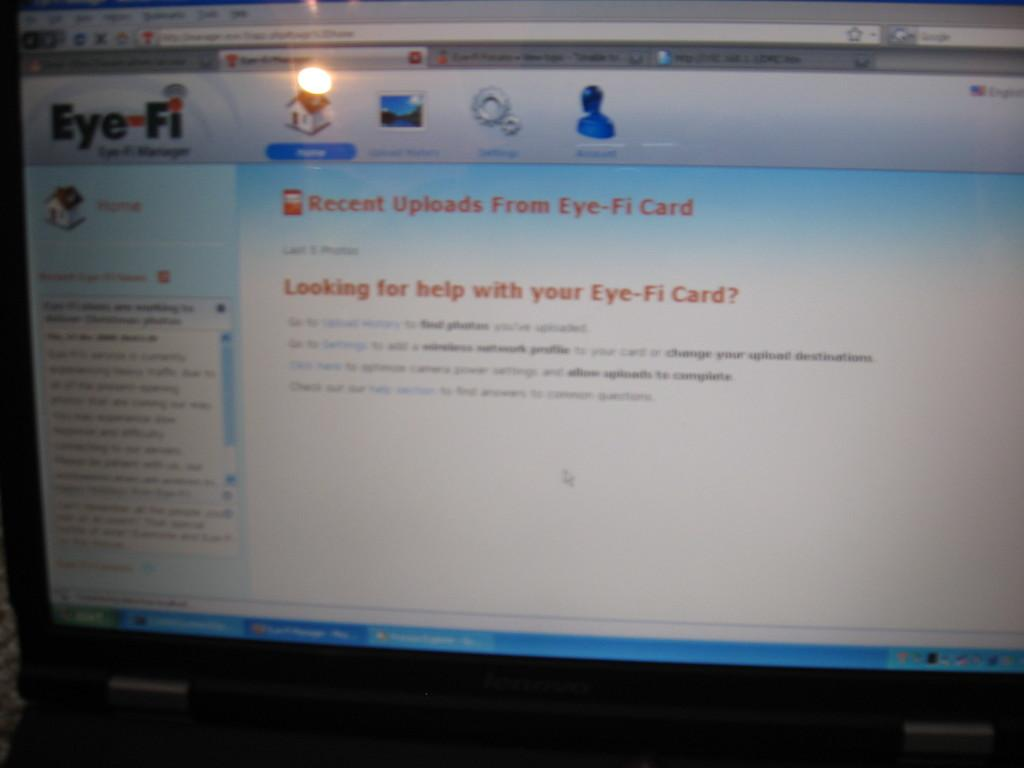What is the main object in the image? There is a computer screen in the image. What is displayed on the computer screen? The computer screen displays a house. Are there any other elements visible on the computer screen? Yes, there are other icons visible on the computer screen. What type of stew is being cooked on the computer screen? There is no stew being cooked on the computer screen; it displays a house and other icons. Can you see a snail moving across the computer screen? There is no snail present on the computer screen; it only displays a house and other icons. 